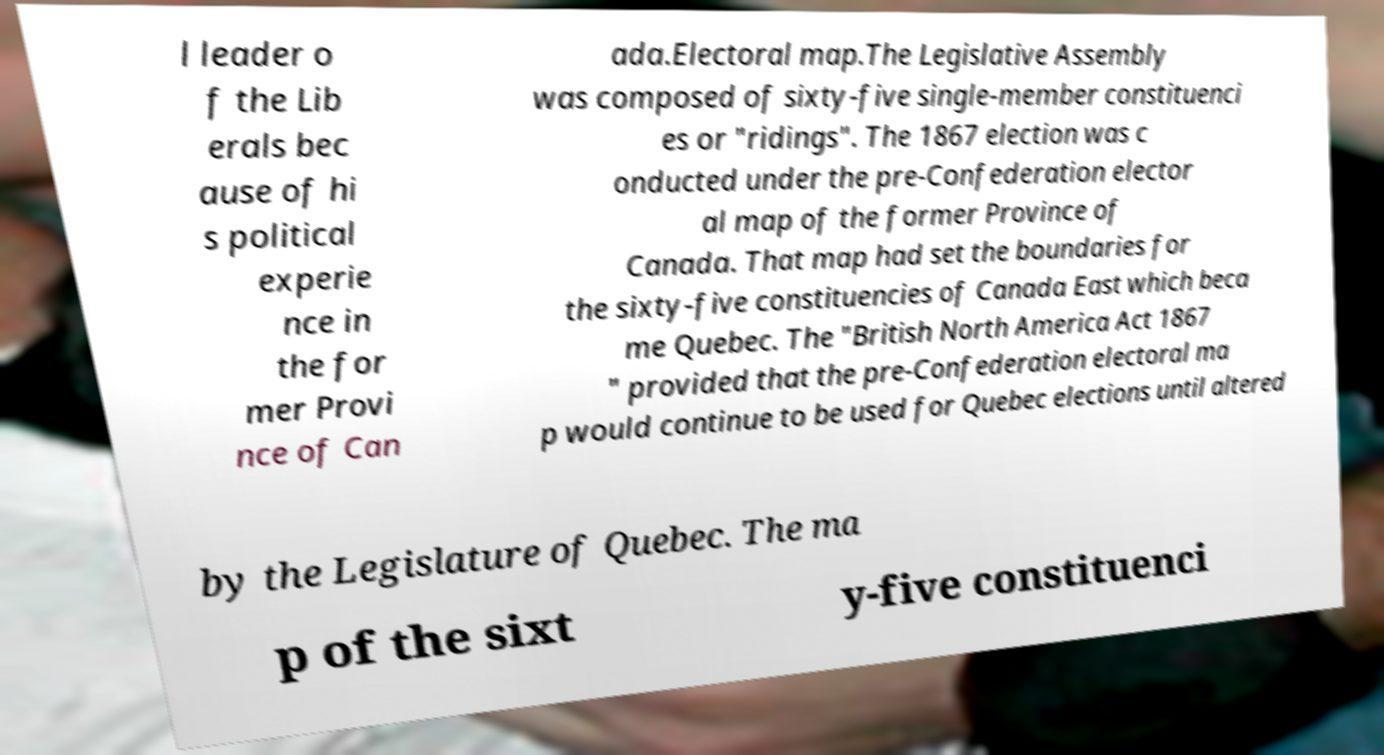Please read and relay the text visible in this image. What does it say? l leader o f the Lib erals bec ause of hi s political experie nce in the for mer Provi nce of Can ada.Electoral map.The Legislative Assembly was composed of sixty-five single-member constituenci es or "ridings". The 1867 election was c onducted under the pre-Confederation elector al map of the former Province of Canada. That map had set the boundaries for the sixty-five constituencies of Canada East which beca me Quebec. The "British North America Act 1867 " provided that the pre-Confederation electoral ma p would continue to be used for Quebec elections until altered by the Legislature of Quebec. The ma p of the sixt y-five constituenci 